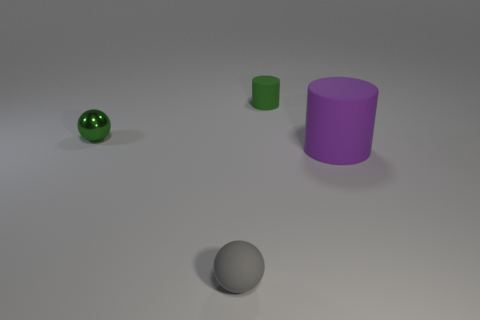How many other things are there of the same material as the large purple cylinder?
Keep it short and to the point. 2. There is a small green thing that is on the right side of the thing that is left of the small object in front of the tiny metallic ball; what is its shape?
Your answer should be compact. Cylinder. Is the number of green cylinders on the left side of the tiny gray ball less than the number of purple things in front of the big purple cylinder?
Ensure brevity in your answer.  No. Is there a cylinder that has the same color as the metallic ball?
Ensure brevity in your answer.  Yes. Does the large thing have the same material as the tiny green thing that is in front of the green rubber object?
Offer a very short reply. No. Are there any large matte cylinders to the left of the tiny rubber thing that is behind the gray thing?
Your answer should be compact. No. What is the color of the small thing that is behind the purple thing and to the right of the tiny shiny sphere?
Your answer should be compact. Green. How big is the matte ball?
Provide a succinct answer. Small. How many matte spheres are the same size as the green shiny sphere?
Provide a succinct answer. 1. Are the small object that is right of the gray matte ball and the tiny ball behind the large object made of the same material?
Provide a short and direct response. No. 